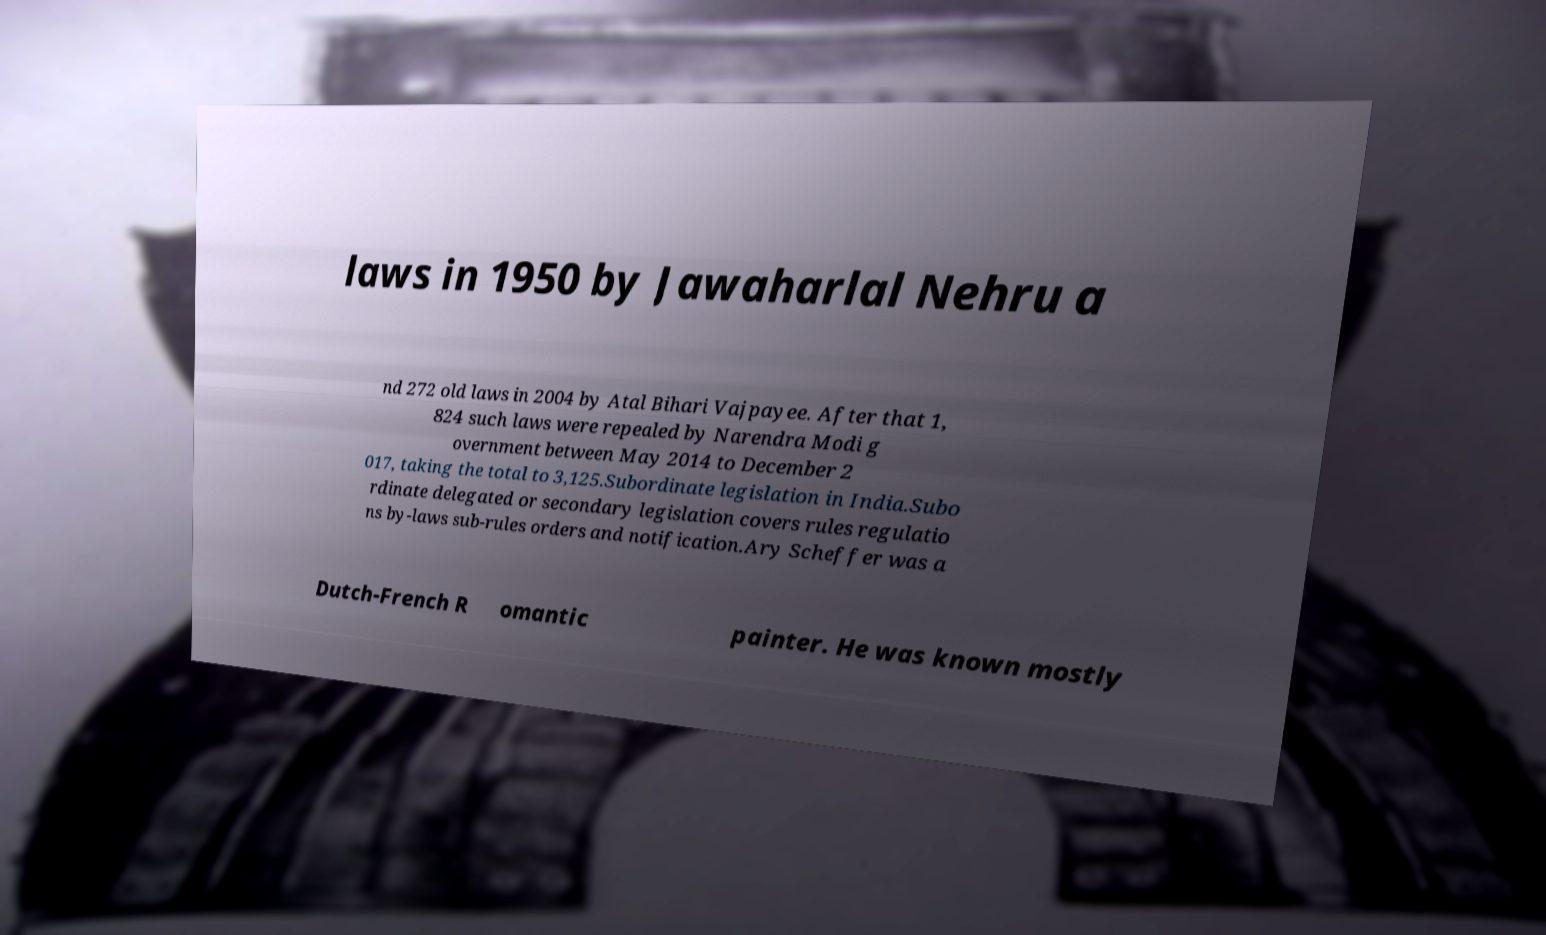Please identify and transcribe the text found in this image. laws in 1950 by Jawaharlal Nehru a nd 272 old laws in 2004 by Atal Bihari Vajpayee. After that 1, 824 such laws were repealed by Narendra Modi g overnment between May 2014 to December 2 017, taking the total to 3,125.Subordinate legislation in India.Subo rdinate delegated or secondary legislation covers rules regulatio ns by-laws sub-rules orders and notification.Ary Scheffer was a Dutch-French R omantic painter. He was known mostly 